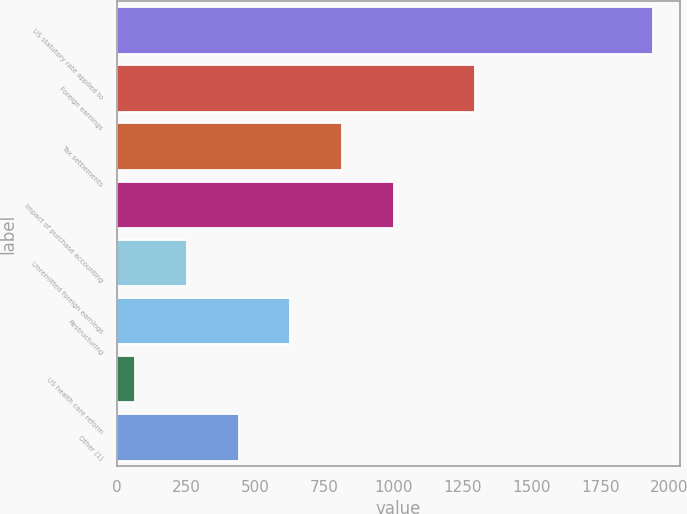<chart> <loc_0><loc_0><loc_500><loc_500><bar_chart><fcel>US statutory rate applied to<fcel>Foreign earnings<fcel>Tax settlements<fcel>Impact of purchase accounting<fcel>Unremitted foreign earnings<fcel>Restructuring<fcel>US health care reform<fcel>Other (1)<nl><fcel>1941<fcel>1296<fcel>815.4<fcel>1003<fcel>252.6<fcel>627.8<fcel>65<fcel>440.2<nl></chart> 